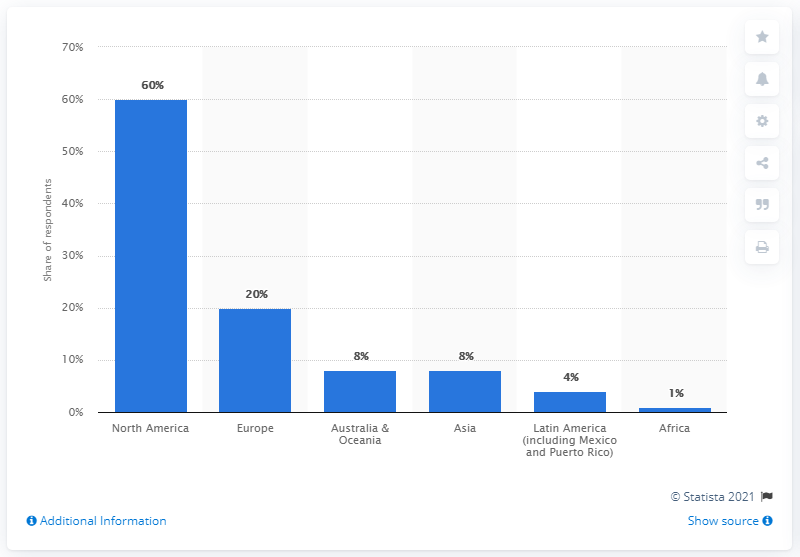Identify some key points in this picture. The majority of game developers were located in North America. Approximately 20% of game developers resided in Europe. 